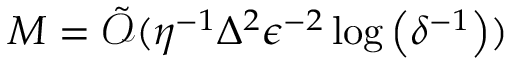Convert formula to latex. <formula><loc_0><loc_0><loc_500><loc_500>\begin{array} { r } { M = \tilde { \mathcal { O } } ( \eta ^ { - 1 } { \Delta } ^ { 2 } { \epsilon } ^ { - 2 } \log \left ( \delta ^ { - 1 } \right ) ) } \end{array}</formula> 